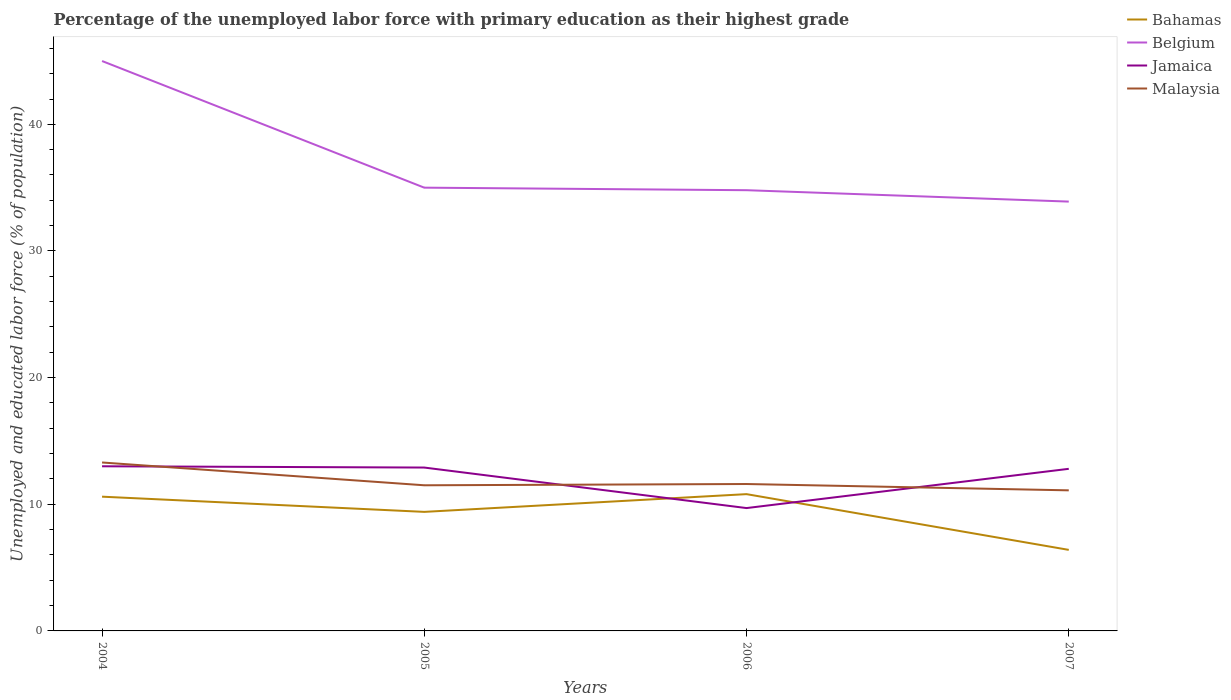Does the line corresponding to Jamaica intersect with the line corresponding to Bahamas?
Provide a short and direct response. Yes. Is the number of lines equal to the number of legend labels?
Your answer should be very brief. Yes. Across all years, what is the maximum percentage of the unemployed labor force with primary education in Belgium?
Ensure brevity in your answer.  33.9. In which year was the percentage of the unemployed labor force with primary education in Malaysia maximum?
Provide a succinct answer. 2007. What is the total percentage of the unemployed labor force with primary education in Jamaica in the graph?
Your answer should be very brief. 3.2. What is the difference between the highest and the second highest percentage of the unemployed labor force with primary education in Bahamas?
Keep it short and to the point. 4.4. What is the difference between the highest and the lowest percentage of the unemployed labor force with primary education in Jamaica?
Your response must be concise. 3. Does the graph contain any zero values?
Keep it short and to the point. No. Does the graph contain grids?
Your answer should be very brief. No. How are the legend labels stacked?
Offer a very short reply. Vertical. What is the title of the graph?
Offer a terse response. Percentage of the unemployed labor force with primary education as their highest grade. What is the label or title of the X-axis?
Ensure brevity in your answer.  Years. What is the label or title of the Y-axis?
Keep it short and to the point. Unemployed and educated labor force (% of population). What is the Unemployed and educated labor force (% of population) in Bahamas in 2004?
Make the answer very short. 10.6. What is the Unemployed and educated labor force (% of population) in Jamaica in 2004?
Make the answer very short. 13. What is the Unemployed and educated labor force (% of population) of Malaysia in 2004?
Your answer should be compact. 13.3. What is the Unemployed and educated labor force (% of population) of Bahamas in 2005?
Keep it short and to the point. 9.4. What is the Unemployed and educated labor force (% of population) of Jamaica in 2005?
Your answer should be very brief. 12.9. What is the Unemployed and educated labor force (% of population) in Bahamas in 2006?
Offer a terse response. 10.8. What is the Unemployed and educated labor force (% of population) of Belgium in 2006?
Provide a short and direct response. 34.8. What is the Unemployed and educated labor force (% of population) in Jamaica in 2006?
Keep it short and to the point. 9.7. What is the Unemployed and educated labor force (% of population) in Malaysia in 2006?
Ensure brevity in your answer.  11.6. What is the Unemployed and educated labor force (% of population) in Bahamas in 2007?
Provide a succinct answer. 6.4. What is the Unemployed and educated labor force (% of population) of Belgium in 2007?
Ensure brevity in your answer.  33.9. What is the Unemployed and educated labor force (% of population) in Jamaica in 2007?
Ensure brevity in your answer.  12.8. What is the Unemployed and educated labor force (% of population) in Malaysia in 2007?
Your response must be concise. 11.1. Across all years, what is the maximum Unemployed and educated labor force (% of population) in Bahamas?
Your response must be concise. 10.8. Across all years, what is the maximum Unemployed and educated labor force (% of population) of Belgium?
Provide a short and direct response. 45. Across all years, what is the maximum Unemployed and educated labor force (% of population) in Malaysia?
Give a very brief answer. 13.3. Across all years, what is the minimum Unemployed and educated labor force (% of population) in Bahamas?
Make the answer very short. 6.4. Across all years, what is the minimum Unemployed and educated labor force (% of population) in Belgium?
Your answer should be very brief. 33.9. Across all years, what is the minimum Unemployed and educated labor force (% of population) in Jamaica?
Offer a terse response. 9.7. Across all years, what is the minimum Unemployed and educated labor force (% of population) in Malaysia?
Your answer should be very brief. 11.1. What is the total Unemployed and educated labor force (% of population) in Bahamas in the graph?
Ensure brevity in your answer.  37.2. What is the total Unemployed and educated labor force (% of population) in Belgium in the graph?
Make the answer very short. 148.7. What is the total Unemployed and educated labor force (% of population) in Jamaica in the graph?
Keep it short and to the point. 48.4. What is the total Unemployed and educated labor force (% of population) of Malaysia in the graph?
Provide a short and direct response. 47.5. What is the difference between the Unemployed and educated labor force (% of population) in Jamaica in 2004 and that in 2005?
Your answer should be very brief. 0.1. What is the difference between the Unemployed and educated labor force (% of population) of Malaysia in 2004 and that in 2005?
Your answer should be very brief. 1.8. What is the difference between the Unemployed and educated labor force (% of population) of Belgium in 2004 and that in 2006?
Offer a very short reply. 10.2. What is the difference between the Unemployed and educated labor force (% of population) of Jamaica in 2004 and that in 2006?
Ensure brevity in your answer.  3.3. What is the difference between the Unemployed and educated labor force (% of population) of Malaysia in 2004 and that in 2006?
Offer a terse response. 1.7. What is the difference between the Unemployed and educated labor force (% of population) in Bahamas in 2005 and that in 2006?
Offer a very short reply. -1.4. What is the difference between the Unemployed and educated labor force (% of population) of Belgium in 2005 and that in 2006?
Give a very brief answer. 0.2. What is the difference between the Unemployed and educated labor force (% of population) of Jamaica in 2005 and that in 2006?
Offer a terse response. 3.2. What is the difference between the Unemployed and educated labor force (% of population) of Bahamas in 2005 and that in 2007?
Your response must be concise. 3. What is the difference between the Unemployed and educated labor force (% of population) in Malaysia in 2005 and that in 2007?
Ensure brevity in your answer.  0.4. What is the difference between the Unemployed and educated labor force (% of population) in Jamaica in 2006 and that in 2007?
Your response must be concise. -3.1. What is the difference between the Unemployed and educated labor force (% of population) in Malaysia in 2006 and that in 2007?
Provide a short and direct response. 0.5. What is the difference between the Unemployed and educated labor force (% of population) of Bahamas in 2004 and the Unemployed and educated labor force (% of population) of Belgium in 2005?
Make the answer very short. -24.4. What is the difference between the Unemployed and educated labor force (% of population) of Bahamas in 2004 and the Unemployed and educated labor force (% of population) of Jamaica in 2005?
Provide a short and direct response. -2.3. What is the difference between the Unemployed and educated labor force (% of population) in Bahamas in 2004 and the Unemployed and educated labor force (% of population) in Malaysia in 2005?
Offer a very short reply. -0.9. What is the difference between the Unemployed and educated labor force (% of population) of Belgium in 2004 and the Unemployed and educated labor force (% of population) of Jamaica in 2005?
Keep it short and to the point. 32.1. What is the difference between the Unemployed and educated labor force (% of population) in Belgium in 2004 and the Unemployed and educated labor force (% of population) in Malaysia in 2005?
Your response must be concise. 33.5. What is the difference between the Unemployed and educated labor force (% of population) in Bahamas in 2004 and the Unemployed and educated labor force (% of population) in Belgium in 2006?
Your response must be concise. -24.2. What is the difference between the Unemployed and educated labor force (% of population) of Belgium in 2004 and the Unemployed and educated labor force (% of population) of Jamaica in 2006?
Your answer should be very brief. 35.3. What is the difference between the Unemployed and educated labor force (% of population) of Belgium in 2004 and the Unemployed and educated labor force (% of population) of Malaysia in 2006?
Ensure brevity in your answer.  33.4. What is the difference between the Unemployed and educated labor force (% of population) in Bahamas in 2004 and the Unemployed and educated labor force (% of population) in Belgium in 2007?
Offer a very short reply. -23.3. What is the difference between the Unemployed and educated labor force (% of population) in Belgium in 2004 and the Unemployed and educated labor force (% of population) in Jamaica in 2007?
Make the answer very short. 32.2. What is the difference between the Unemployed and educated labor force (% of population) of Belgium in 2004 and the Unemployed and educated labor force (% of population) of Malaysia in 2007?
Provide a succinct answer. 33.9. What is the difference between the Unemployed and educated labor force (% of population) of Bahamas in 2005 and the Unemployed and educated labor force (% of population) of Belgium in 2006?
Your answer should be compact. -25.4. What is the difference between the Unemployed and educated labor force (% of population) in Bahamas in 2005 and the Unemployed and educated labor force (% of population) in Jamaica in 2006?
Give a very brief answer. -0.3. What is the difference between the Unemployed and educated labor force (% of population) in Bahamas in 2005 and the Unemployed and educated labor force (% of population) in Malaysia in 2006?
Your response must be concise. -2.2. What is the difference between the Unemployed and educated labor force (% of population) in Belgium in 2005 and the Unemployed and educated labor force (% of population) in Jamaica in 2006?
Keep it short and to the point. 25.3. What is the difference between the Unemployed and educated labor force (% of population) of Belgium in 2005 and the Unemployed and educated labor force (% of population) of Malaysia in 2006?
Provide a succinct answer. 23.4. What is the difference between the Unemployed and educated labor force (% of population) in Jamaica in 2005 and the Unemployed and educated labor force (% of population) in Malaysia in 2006?
Make the answer very short. 1.3. What is the difference between the Unemployed and educated labor force (% of population) of Bahamas in 2005 and the Unemployed and educated labor force (% of population) of Belgium in 2007?
Provide a short and direct response. -24.5. What is the difference between the Unemployed and educated labor force (% of population) in Belgium in 2005 and the Unemployed and educated labor force (% of population) in Malaysia in 2007?
Your answer should be very brief. 23.9. What is the difference between the Unemployed and educated labor force (% of population) in Bahamas in 2006 and the Unemployed and educated labor force (% of population) in Belgium in 2007?
Offer a very short reply. -23.1. What is the difference between the Unemployed and educated labor force (% of population) of Bahamas in 2006 and the Unemployed and educated labor force (% of population) of Jamaica in 2007?
Your answer should be compact. -2. What is the difference between the Unemployed and educated labor force (% of population) of Belgium in 2006 and the Unemployed and educated labor force (% of population) of Malaysia in 2007?
Keep it short and to the point. 23.7. What is the difference between the Unemployed and educated labor force (% of population) in Jamaica in 2006 and the Unemployed and educated labor force (% of population) in Malaysia in 2007?
Give a very brief answer. -1.4. What is the average Unemployed and educated labor force (% of population) in Belgium per year?
Your answer should be compact. 37.17. What is the average Unemployed and educated labor force (% of population) in Malaysia per year?
Make the answer very short. 11.88. In the year 2004, what is the difference between the Unemployed and educated labor force (% of population) in Bahamas and Unemployed and educated labor force (% of population) in Belgium?
Provide a short and direct response. -34.4. In the year 2004, what is the difference between the Unemployed and educated labor force (% of population) of Bahamas and Unemployed and educated labor force (% of population) of Jamaica?
Offer a very short reply. -2.4. In the year 2004, what is the difference between the Unemployed and educated labor force (% of population) in Belgium and Unemployed and educated labor force (% of population) in Jamaica?
Give a very brief answer. 32. In the year 2004, what is the difference between the Unemployed and educated labor force (% of population) in Belgium and Unemployed and educated labor force (% of population) in Malaysia?
Make the answer very short. 31.7. In the year 2005, what is the difference between the Unemployed and educated labor force (% of population) in Bahamas and Unemployed and educated labor force (% of population) in Belgium?
Offer a terse response. -25.6. In the year 2005, what is the difference between the Unemployed and educated labor force (% of population) of Bahamas and Unemployed and educated labor force (% of population) of Jamaica?
Provide a short and direct response. -3.5. In the year 2005, what is the difference between the Unemployed and educated labor force (% of population) of Belgium and Unemployed and educated labor force (% of population) of Jamaica?
Your answer should be very brief. 22.1. In the year 2005, what is the difference between the Unemployed and educated labor force (% of population) of Belgium and Unemployed and educated labor force (% of population) of Malaysia?
Ensure brevity in your answer.  23.5. In the year 2005, what is the difference between the Unemployed and educated labor force (% of population) in Jamaica and Unemployed and educated labor force (% of population) in Malaysia?
Offer a very short reply. 1.4. In the year 2006, what is the difference between the Unemployed and educated labor force (% of population) in Bahamas and Unemployed and educated labor force (% of population) in Jamaica?
Ensure brevity in your answer.  1.1. In the year 2006, what is the difference between the Unemployed and educated labor force (% of population) of Belgium and Unemployed and educated labor force (% of population) of Jamaica?
Offer a very short reply. 25.1. In the year 2006, what is the difference between the Unemployed and educated labor force (% of population) of Belgium and Unemployed and educated labor force (% of population) of Malaysia?
Offer a terse response. 23.2. In the year 2007, what is the difference between the Unemployed and educated labor force (% of population) of Bahamas and Unemployed and educated labor force (% of population) of Belgium?
Provide a succinct answer. -27.5. In the year 2007, what is the difference between the Unemployed and educated labor force (% of population) in Bahamas and Unemployed and educated labor force (% of population) in Jamaica?
Your answer should be compact. -6.4. In the year 2007, what is the difference between the Unemployed and educated labor force (% of population) in Bahamas and Unemployed and educated labor force (% of population) in Malaysia?
Provide a short and direct response. -4.7. In the year 2007, what is the difference between the Unemployed and educated labor force (% of population) in Belgium and Unemployed and educated labor force (% of population) in Jamaica?
Ensure brevity in your answer.  21.1. In the year 2007, what is the difference between the Unemployed and educated labor force (% of population) of Belgium and Unemployed and educated labor force (% of population) of Malaysia?
Your answer should be compact. 22.8. What is the ratio of the Unemployed and educated labor force (% of population) in Bahamas in 2004 to that in 2005?
Offer a terse response. 1.13. What is the ratio of the Unemployed and educated labor force (% of population) of Belgium in 2004 to that in 2005?
Keep it short and to the point. 1.29. What is the ratio of the Unemployed and educated labor force (% of population) in Jamaica in 2004 to that in 2005?
Keep it short and to the point. 1.01. What is the ratio of the Unemployed and educated labor force (% of population) of Malaysia in 2004 to that in 2005?
Offer a terse response. 1.16. What is the ratio of the Unemployed and educated labor force (% of population) of Bahamas in 2004 to that in 2006?
Offer a terse response. 0.98. What is the ratio of the Unemployed and educated labor force (% of population) in Belgium in 2004 to that in 2006?
Offer a terse response. 1.29. What is the ratio of the Unemployed and educated labor force (% of population) in Jamaica in 2004 to that in 2006?
Provide a short and direct response. 1.34. What is the ratio of the Unemployed and educated labor force (% of population) of Malaysia in 2004 to that in 2006?
Offer a very short reply. 1.15. What is the ratio of the Unemployed and educated labor force (% of population) in Bahamas in 2004 to that in 2007?
Keep it short and to the point. 1.66. What is the ratio of the Unemployed and educated labor force (% of population) of Belgium in 2004 to that in 2007?
Offer a very short reply. 1.33. What is the ratio of the Unemployed and educated labor force (% of population) in Jamaica in 2004 to that in 2007?
Provide a short and direct response. 1.02. What is the ratio of the Unemployed and educated labor force (% of population) in Malaysia in 2004 to that in 2007?
Offer a very short reply. 1.2. What is the ratio of the Unemployed and educated labor force (% of population) in Bahamas in 2005 to that in 2006?
Your answer should be compact. 0.87. What is the ratio of the Unemployed and educated labor force (% of population) of Jamaica in 2005 to that in 2006?
Keep it short and to the point. 1.33. What is the ratio of the Unemployed and educated labor force (% of population) of Bahamas in 2005 to that in 2007?
Ensure brevity in your answer.  1.47. What is the ratio of the Unemployed and educated labor force (% of population) of Belgium in 2005 to that in 2007?
Your answer should be compact. 1.03. What is the ratio of the Unemployed and educated labor force (% of population) of Jamaica in 2005 to that in 2007?
Keep it short and to the point. 1.01. What is the ratio of the Unemployed and educated labor force (% of population) of Malaysia in 2005 to that in 2007?
Provide a short and direct response. 1.04. What is the ratio of the Unemployed and educated labor force (% of population) in Bahamas in 2006 to that in 2007?
Make the answer very short. 1.69. What is the ratio of the Unemployed and educated labor force (% of population) of Belgium in 2006 to that in 2007?
Provide a succinct answer. 1.03. What is the ratio of the Unemployed and educated labor force (% of population) of Jamaica in 2006 to that in 2007?
Give a very brief answer. 0.76. What is the ratio of the Unemployed and educated labor force (% of population) in Malaysia in 2006 to that in 2007?
Make the answer very short. 1.04. What is the difference between the highest and the lowest Unemployed and educated labor force (% of population) of Jamaica?
Offer a very short reply. 3.3. 